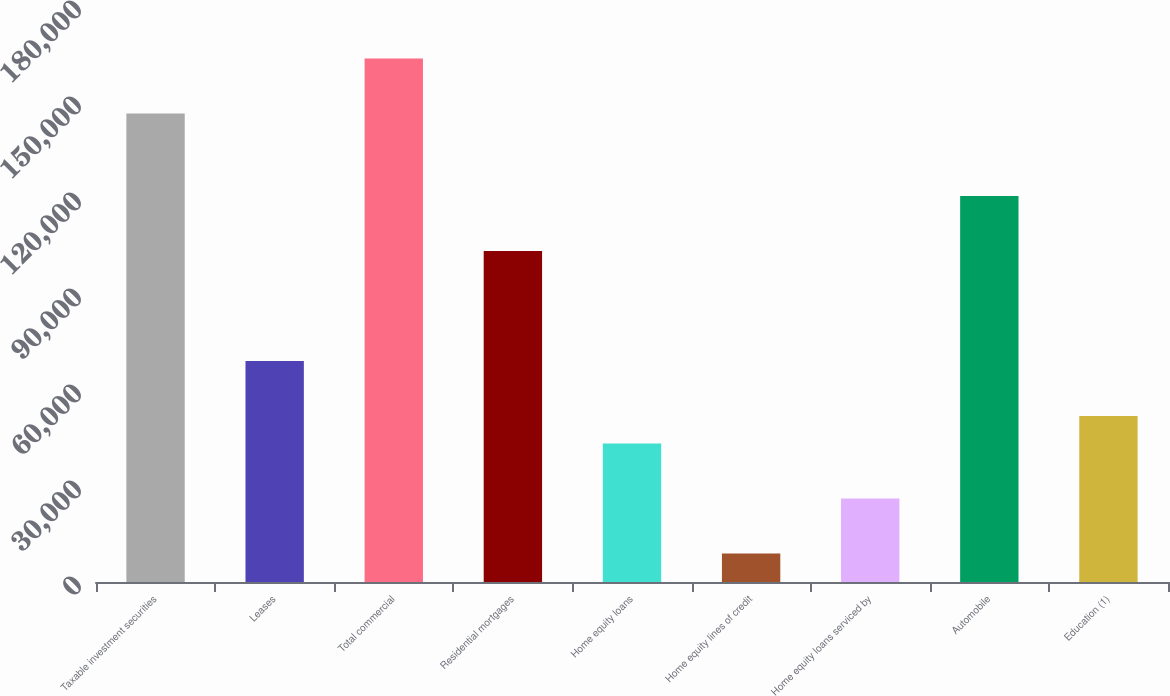Convert chart to OTSL. <chart><loc_0><loc_0><loc_500><loc_500><bar_chart><fcel>Taxable investment securities<fcel>Leases<fcel>Total commercial<fcel>Residential mortgages<fcel>Home equity loans<fcel>Home equity lines of credit<fcel>Home equity loans serviced by<fcel>Automobile<fcel>Education (1)<nl><fcel>146424<fcel>69065<fcel>163616<fcel>103447<fcel>43278.5<fcel>8896.5<fcel>26087.5<fcel>120638<fcel>51874<nl></chart> 